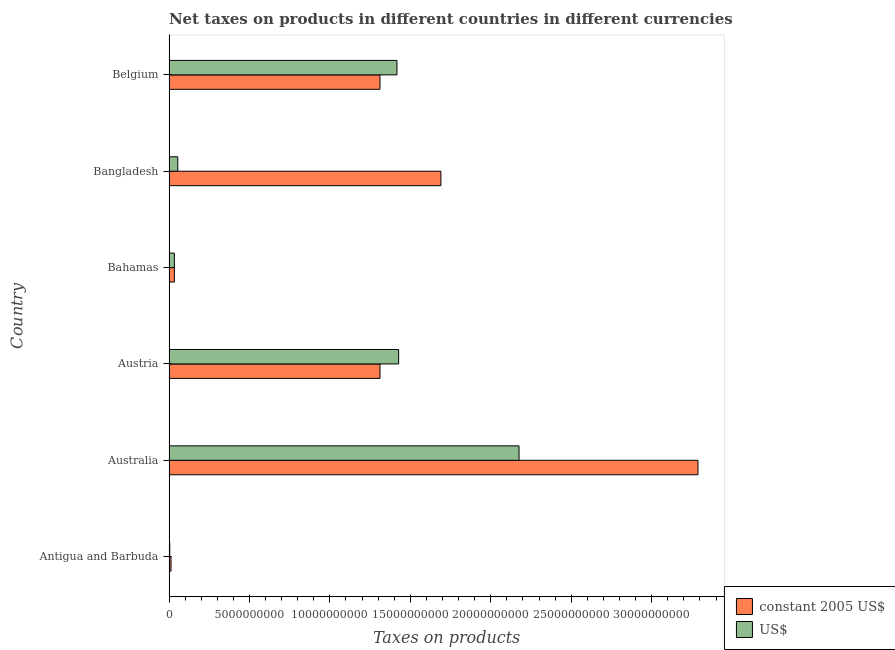How many bars are there on the 5th tick from the top?
Offer a very short reply. 2. What is the net taxes in constant 2005 us$ in Australia?
Keep it short and to the point. 3.29e+1. Across all countries, what is the maximum net taxes in constant 2005 us$?
Offer a terse response. 3.29e+1. Across all countries, what is the minimum net taxes in us$?
Your answer should be compact. 4.67e+07. In which country was the net taxes in constant 2005 us$ maximum?
Your response must be concise. Australia. In which country was the net taxes in us$ minimum?
Offer a terse response. Antigua and Barbuda. What is the total net taxes in us$ in the graph?
Ensure brevity in your answer.  5.11e+1. What is the difference between the net taxes in us$ in Australia and that in Belgium?
Your answer should be very brief. 7.59e+09. What is the difference between the net taxes in constant 2005 us$ in Australia and the net taxes in us$ in Antigua and Barbuda?
Your response must be concise. 3.28e+1. What is the average net taxes in us$ per country?
Keep it short and to the point. 8.52e+09. What is the difference between the net taxes in us$ and net taxes in constant 2005 us$ in Bangladesh?
Your answer should be very brief. -1.64e+1. What is the ratio of the net taxes in constant 2005 us$ in Austria to that in Bangladesh?
Provide a succinct answer. 0.78. Is the difference between the net taxes in us$ in Bangladesh and Belgium greater than the difference between the net taxes in constant 2005 us$ in Bangladesh and Belgium?
Provide a succinct answer. No. What is the difference between the highest and the second highest net taxes in constant 2005 us$?
Provide a short and direct response. 1.60e+1. What is the difference between the highest and the lowest net taxes in us$?
Ensure brevity in your answer.  2.17e+1. In how many countries, is the net taxes in us$ greater than the average net taxes in us$ taken over all countries?
Your answer should be very brief. 3. What does the 1st bar from the top in Australia represents?
Your answer should be very brief. US$. What does the 2nd bar from the bottom in Belgium represents?
Provide a succinct answer. US$. How many bars are there?
Ensure brevity in your answer.  12. What is the difference between two consecutive major ticks on the X-axis?
Give a very brief answer. 5.00e+09. Does the graph contain any zero values?
Keep it short and to the point. No. Does the graph contain grids?
Your answer should be compact. No. What is the title of the graph?
Offer a very short reply. Net taxes on products in different countries in different currencies. Does "Merchandise imports" appear as one of the legend labels in the graph?
Make the answer very short. No. What is the label or title of the X-axis?
Offer a very short reply. Taxes on products. What is the label or title of the Y-axis?
Offer a terse response. Country. What is the Taxes on products in constant 2005 US$ in Antigua and Barbuda?
Your response must be concise. 1.26e+08. What is the Taxes on products in US$ in Antigua and Barbuda?
Keep it short and to the point. 4.67e+07. What is the Taxes on products of constant 2005 US$ in Australia?
Your answer should be very brief. 3.29e+1. What is the Taxes on products in US$ in Australia?
Offer a very short reply. 2.18e+1. What is the Taxes on products of constant 2005 US$ in Austria?
Your answer should be compact. 1.31e+1. What is the Taxes on products in US$ in Austria?
Your answer should be compact. 1.43e+1. What is the Taxes on products in constant 2005 US$ in Bahamas?
Ensure brevity in your answer.  3.35e+08. What is the Taxes on products of US$ in Bahamas?
Your answer should be compact. 3.35e+08. What is the Taxes on products in constant 2005 US$ in Bangladesh?
Your response must be concise. 1.69e+1. What is the Taxes on products of US$ in Bangladesh?
Give a very brief answer. 5.45e+08. What is the Taxes on products of constant 2005 US$ in Belgium?
Your response must be concise. 1.31e+1. What is the Taxes on products in US$ in Belgium?
Your response must be concise. 1.42e+1. Across all countries, what is the maximum Taxes on products in constant 2005 US$?
Provide a succinct answer. 3.29e+1. Across all countries, what is the maximum Taxes on products in US$?
Keep it short and to the point. 2.18e+1. Across all countries, what is the minimum Taxes on products in constant 2005 US$?
Offer a very short reply. 1.26e+08. Across all countries, what is the minimum Taxes on products of US$?
Your response must be concise. 4.67e+07. What is the total Taxes on products in constant 2005 US$ in the graph?
Keep it short and to the point. 7.65e+1. What is the total Taxes on products in US$ in the graph?
Your answer should be very brief. 5.11e+1. What is the difference between the Taxes on products in constant 2005 US$ in Antigua and Barbuda and that in Australia?
Offer a terse response. -3.28e+1. What is the difference between the Taxes on products of US$ in Antigua and Barbuda and that in Australia?
Give a very brief answer. -2.17e+1. What is the difference between the Taxes on products of constant 2005 US$ in Antigua and Barbuda and that in Austria?
Offer a very short reply. -1.30e+1. What is the difference between the Taxes on products of US$ in Antigua and Barbuda and that in Austria?
Ensure brevity in your answer.  -1.42e+1. What is the difference between the Taxes on products of constant 2005 US$ in Antigua and Barbuda and that in Bahamas?
Your answer should be compact. -2.09e+08. What is the difference between the Taxes on products in US$ in Antigua and Barbuda and that in Bahamas?
Give a very brief answer. -2.89e+08. What is the difference between the Taxes on products of constant 2005 US$ in Antigua and Barbuda and that in Bangladesh?
Give a very brief answer. -1.68e+1. What is the difference between the Taxes on products in US$ in Antigua and Barbuda and that in Bangladesh?
Provide a short and direct response. -4.98e+08. What is the difference between the Taxes on products in constant 2005 US$ in Antigua and Barbuda and that in Belgium?
Offer a very short reply. -1.30e+1. What is the difference between the Taxes on products in US$ in Antigua and Barbuda and that in Belgium?
Offer a very short reply. -1.41e+1. What is the difference between the Taxes on products in constant 2005 US$ in Australia and that in Austria?
Your answer should be compact. 1.98e+1. What is the difference between the Taxes on products in US$ in Australia and that in Austria?
Keep it short and to the point. 7.48e+09. What is the difference between the Taxes on products in constant 2005 US$ in Australia and that in Bahamas?
Your response must be concise. 3.25e+1. What is the difference between the Taxes on products of US$ in Australia and that in Bahamas?
Your answer should be very brief. 2.14e+1. What is the difference between the Taxes on products of constant 2005 US$ in Australia and that in Bangladesh?
Give a very brief answer. 1.60e+1. What is the difference between the Taxes on products of US$ in Australia and that in Bangladesh?
Ensure brevity in your answer.  2.12e+1. What is the difference between the Taxes on products of constant 2005 US$ in Australia and that in Belgium?
Your answer should be compact. 1.98e+1. What is the difference between the Taxes on products of US$ in Australia and that in Belgium?
Give a very brief answer. 7.59e+09. What is the difference between the Taxes on products in constant 2005 US$ in Austria and that in Bahamas?
Make the answer very short. 1.28e+1. What is the difference between the Taxes on products in US$ in Austria and that in Bahamas?
Your response must be concise. 1.39e+1. What is the difference between the Taxes on products of constant 2005 US$ in Austria and that in Bangladesh?
Ensure brevity in your answer.  -3.79e+09. What is the difference between the Taxes on products in US$ in Austria and that in Bangladesh?
Offer a terse response. 1.37e+1. What is the difference between the Taxes on products of constant 2005 US$ in Austria and that in Belgium?
Keep it short and to the point. 1.22e+06. What is the difference between the Taxes on products of US$ in Austria and that in Belgium?
Keep it short and to the point. 1.05e+08. What is the difference between the Taxes on products of constant 2005 US$ in Bahamas and that in Bangladesh?
Offer a very short reply. -1.66e+1. What is the difference between the Taxes on products of US$ in Bahamas and that in Bangladesh?
Your answer should be very brief. -2.10e+08. What is the difference between the Taxes on products in constant 2005 US$ in Bahamas and that in Belgium?
Provide a succinct answer. -1.28e+1. What is the difference between the Taxes on products of US$ in Bahamas and that in Belgium?
Give a very brief answer. -1.38e+1. What is the difference between the Taxes on products in constant 2005 US$ in Bangladesh and that in Belgium?
Keep it short and to the point. 3.79e+09. What is the difference between the Taxes on products of US$ in Bangladesh and that in Belgium?
Make the answer very short. -1.36e+1. What is the difference between the Taxes on products in constant 2005 US$ in Antigua and Barbuda and the Taxes on products in US$ in Australia?
Your answer should be compact. -2.16e+1. What is the difference between the Taxes on products in constant 2005 US$ in Antigua and Barbuda and the Taxes on products in US$ in Austria?
Your answer should be compact. -1.41e+1. What is the difference between the Taxes on products in constant 2005 US$ in Antigua and Barbuda and the Taxes on products in US$ in Bahamas?
Provide a succinct answer. -2.09e+08. What is the difference between the Taxes on products of constant 2005 US$ in Antigua and Barbuda and the Taxes on products of US$ in Bangladesh?
Your response must be concise. -4.19e+08. What is the difference between the Taxes on products in constant 2005 US$ in Antigua and Barbuda and the Taxes on products in US$ in Belgium?
Your answer should be compact. -1.40e+1. What is the difference between the Taxes on products of constant 2005 US$ in Australia and the Taxes on products of US$ in Austria?
Keep it short and to the point. 1.86e+1. What is the difference between the Taxes on products of constant 2005 US$ in Australia and the Taxes on products of US$ in Bahamas?
Give a very brief answer. 3.25e+1. What is the difference between the Taxes on products of constant 2005 US$ in Australia and the Taxes on products of US$ in Bangladesh?
Ensure brevity in your answer.  3.23e+1. What is the difference between the Taxes on products of constant 2005 US$ in Australia and the Taxes on products of US$ in Belgium?
Your response must be concise. 1.87e+1. What is the difference between the Taxes on products in constant 2005 US$ in Austria and the Taxes on products in US$ in Bahamas?
Provide a short and direct response. 1.28e+1. What is the difference between the Taxes on products in constant 2005 US$ in Austria and the Taxes on products in US$ in Bangladesh?
Give a very brief answer. 1.26e+1. What is the difference between the Taxes on products of constant 2005 US$ in Austria and the Taxes on products of US$ in Belgium?
Offer a terse response. -1.05e+09. What is the difference between the Taxes on products in constant 2005 US$ in Bahamas and the Taxes on products in US$ in Bangladesh?
Ensure brevity in your answer.  -2.10e+08. What is the difference between the Taxes on products of constant 2005 US$ in Bahamas and the Taxes on products of US$ in Belgium?
Give a very brief answer. -1.38e+1. What is the difference between the Taxes on products in constant 2005 US$ in Bangladesh and the Taxes on products in US$ in Belgium?
Keep it short and to the point. 2.73e+09. What is the average Taxes on products of constant 2005 US$ per country?
Ensure brevity in your answer.  1.27e+1. What is the average Taxes on products in US$ per country?
Give a very brief answer. 8.52e+09. What is the difference between the Taxes on products of constant 2005 US$ and Taxes on products of US$ in Antigua and Barbuda?
Keep it short and to the point. 7.93e+07. What is the difference between the Taxes on products in constant 2005 US$ and Taxes on products in US$ in Australia?
Provide a short and direct response. 1.11e+1. What is the difference between the Taxes on products in constant 2005 US$ and Taxes on products in US$ in Austria?
Offer a very short reply. -1.16e+09. What is the difference between the Taxes on products in constant 2005 US$ and Taxes on products in US$ in Bangladesh?
Give a very brief answer. 1.64e+1. What is the difference between the Taxes on products of constant 2005 US$ and Taxes on products of US$ in Belgium?
Make the answer very short. -1.06e+09. What is the ratio of the Taxes on products of constant 2005 US$ in Antigua and Barbuda to that in Australia?
Provide a short and direct response. 0. What is the ratio of the Taxes on products of US$ in Antigua and Barbuda to that in Australia?
Offer a terse response. 0. What is the ratio of the Taxes on products in constant 2005 US$ in Antigua and Barbuda to that in Austria?
Provide a short and direct response. 0.01. What is the ratio of the Taxes on products of US$ in Antigua and Barbuda to that in Austria?
Offer a very short reply. 0. What is the ratio of the Taxes on products of constant 2005 US$ in Antigua and Barbuda to that in Bahamas?
Make the answer very short. 0.38. What is the ratio of the Taxes on products in US$ in Antigua and Barbuda to that in Bahamas?
Offer a terse response. 0.14. What is the ratio of the Taxes on products of constant 2005 US$ in Antigua and Barbuda to that in Bangladesh?
Give a very brief answer. 0.01. What is the ratio of the Taxes on products of US$ in Antigua and Barbuda to that in Bangladesh?
Give a very brief answer. 0.09. What is the ratio of the Taxes on products in constant 2005 US$ in Antigua and Barbuda to that in Belgium?
Provide a succinct answer. 0.01. What is the ratio of the Taxes on products of US$ in Antigua and Barbuda to that in Belgium?
Your response must be concise. 0. What is the ratio of the Taxes on products in constant 2005 US$ in Australia to that in Austria?
Provide a short and direct response. 2.51. What is the ratio of the Taxes on products in US$ in Australia to that in Austria?
Ensure brevity in your answer.  1.52. What is the ratio of the Taxes on products in constant 2005 US$ in Australia to that in Bahamas?
Your answer should be compact. 98.03. What is the ratio of the Taxes on products in US$ in Australia to that in Bahamas?
Make the answer very short. 64.87. What is the ratio of the Taxes on products in constant 2005 US$ in Australia to that in Bangladesh?
Offer a terse response. 1.95. What is the ratio of the Taxes on products in US$ in Australia to that in Bangladesh?
Make the answer very short. 39.91. What is the ratio of the Taxes on products of constant 2005 US$ in Australia to that in Belgium?
Keep it short and to the point. 2.51. What is the ratio of the Taxes on products of US$ in Australia to that in Belgium?
Provide a succinct answer. 1.54. What is the ratio of the Taxes on products in constant 2005 US$ in Austria to that in Bahamas?
Make the answer very short. 39.1. What is the ratio of the Taxes on products of US$ in Austria to that in Bahamas?
Ensure brevity in your answer.  42.55. What is the ratio of the Taxes on products in constant 2005 US$ in Austria to that in Bangladesh?
Provide a short and direct response. 0.78. What is the ratio of the Taxes on products of US$ in Austria to that in Bangladesh?
Provide a short and direct response. 26.18. What is the ratio of the Taxes on products in US$ in Austria to that in Belgium?
Offer a terse response. 1.01. What is the ratio of the Taxes on products of constant 2005 US$ in Bahamas to that in Bangladesh?
Your answer should be compact. 0.02. What is the ratio of the Taxes on products in US$ in Bahamas to that in Bangladesh?
Provide a short and direct response. 0.62. What is the ratio of the Taxes on products of constant 2005 US$ in Bahamas to that in Belgium?
Offer a terse response. 0.03. What is the ratio of the Taxes on products of US$ in Bahamas to that in Belgium?
Provide a short and direct response. 0.02. What is the ratio of the Taxes on products in constant 2005 US$ in Bangladesh to that in Belgium?
Your answer should be very brief. 1.29. What is the ratio of the Taxes on products of US$ in Bangladesh to that in Belgium?
Offer a very short reply. 0.04. What is the difference between the highest and the second highest Taxes on products of constant 2005 US$?
Provide a succinct answer. 1.60e+1. What is the difference between the highest and the second highest Taxes on products of US$?
Ensure brevity in your answer.  7.48e+09. What is the difference between the highest and the lowest Taxes on products in constant 2005 US$?
Your answer should be very brief. 3.28e+1. What is the difference between the highest and the lowest Taxes on products of US$?
Provide a short and direct response. 2.17e+1. 